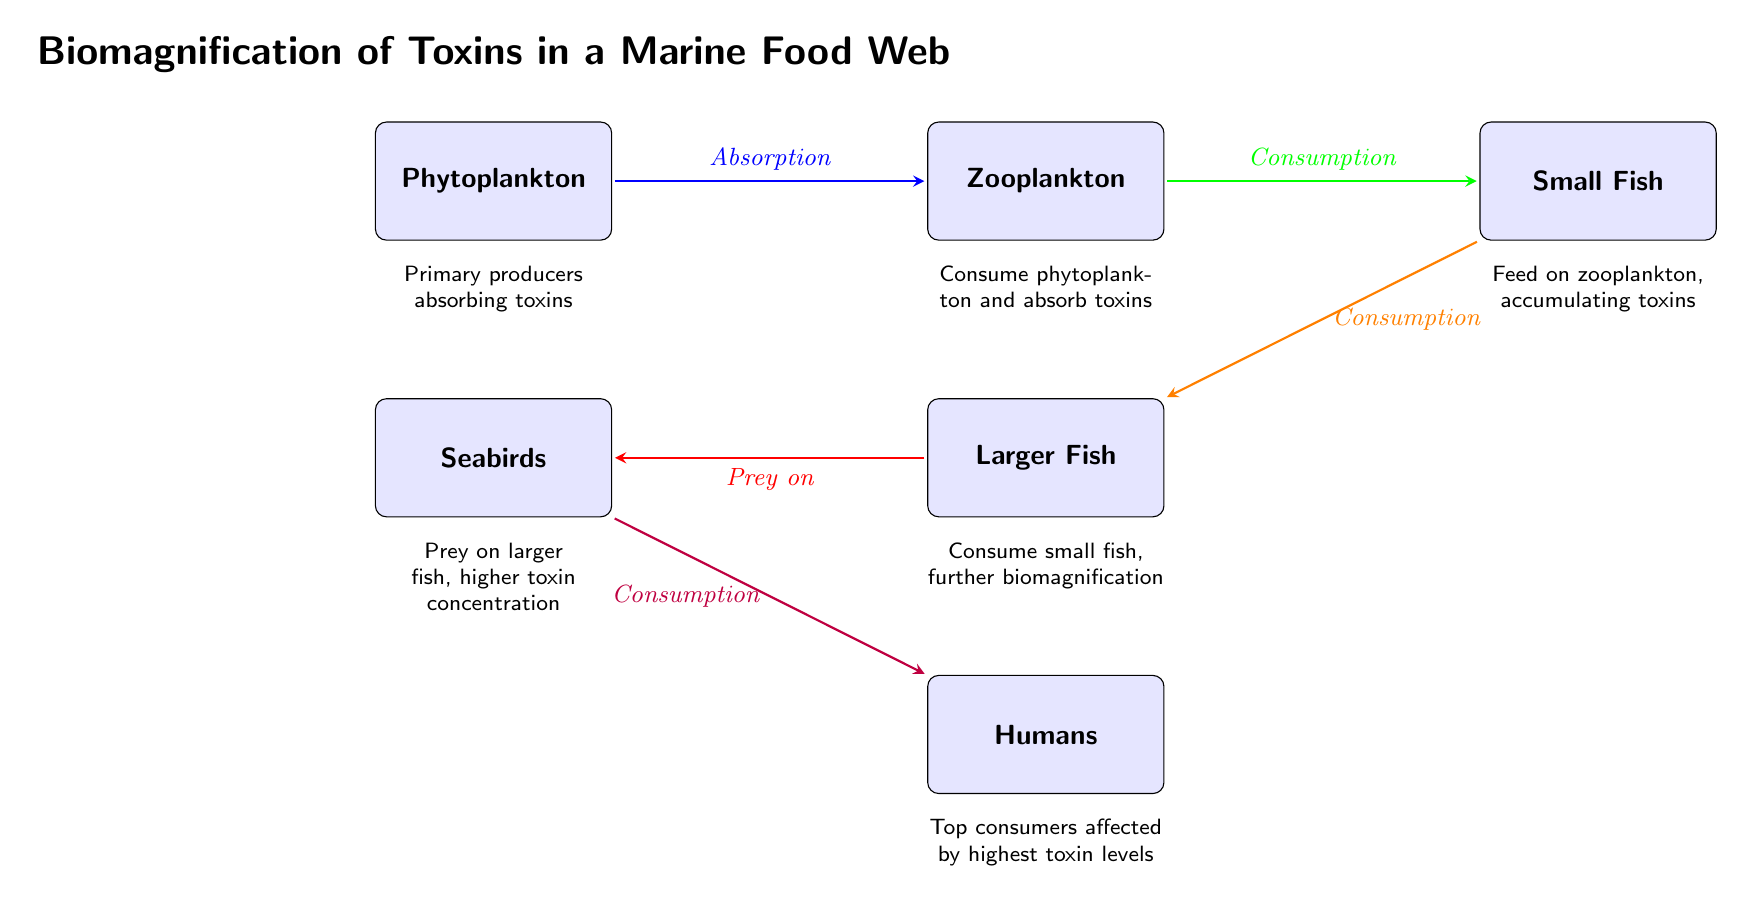What is the first node in the food web? The first node in the food web is labeled as "Phytoplankton." It is located on the far left side of the diagram, representing the primary producers in the marine ecosystem.
Answer: Phytoplankton How many nodes are present in the food web? Counting the number of distinct boxes/nodes in the diagram, we identify six nodes: Phytoplankton, Zooplankton, Small Fish, Larger Fish, Seabirds, and Humans. Therefore, the total number of nodes is six.
Answer: 6 What type of relationship exists between Zooplankton and Small Fish? The relationship between Zooplankton and Small Fish is labeled "Consumption," indicating that Small Fish consume Zooplankton as part of the food chain. This connection is shown with an arrow directed from Zooplankton to Small Fish.
Answer: Consumption Which node has the highest concentration of toxins according to the diagram? The node labeled "Humans" represents the top consumers in this marine food web and is affected by the highest toxin levels due to biomagnification throughout the food chain.
Answer: Humans What does the arrow from Larger Fish to Seabirds indicate? The arrow from Larger Fish to Seabirds indicates the relationship labeled "Prey on," meaning that Seabirds feed on Larger Fish within the food web, showcasing the predator-prey dynamics.
Answer: Prey on How does biomagnification occur in this food web? Biomagnification occurs as each subsequent consumer in the food web accumulates higher levels of toxins by consuming their prey. Starting from Phytoplankton absorbing toxins, Zooplankton consumes them, then Small Fish eats Zooplankton, and this continues up to Humans, each time increasing the concentration of toxins in the higher trophic levels.
Answer: By consuming prey Which node directly absorbs toxins from the environment? The node labeled "Phytoplankton" absorbs toxins from the environment, acting as the primary producers in this food web. This is indicated by the directed arrow leading to Zooplankton.
Answer: Phytoplankton How do Smaller Fish contribute to biomagnification in this food web? Small Fish contribute to biomagnification by feeding on Zooplankton, which has already absorbed toxins. This accumulation process increases the concentration of toxins in Small Fish, which are then consumed by larger fish in the next trophic level.
Answer: By consuming Zooplankton 